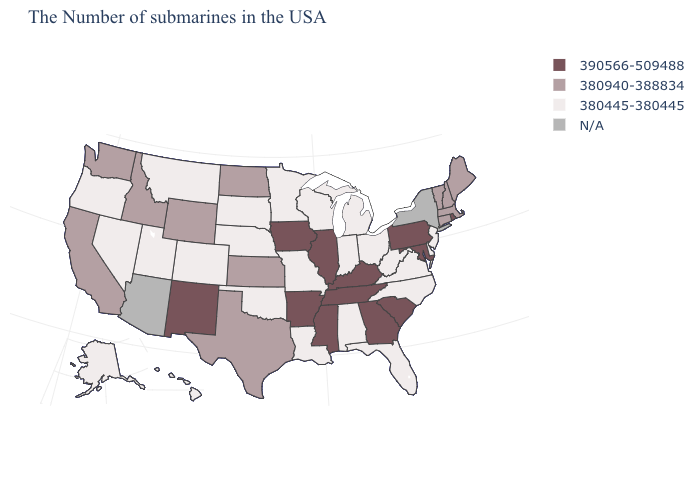Which states have the lowest value in the West?
Give a very brief answer. Colorado, Utah, Montana, Nevada, Oregon, Alaska, Hawaii. What is the value of Michigan?
Keep it brief. 380445-380445. Which states have the lowest value in the MidWest?
Answer briefly. Ohio, Michigan, Indiana, Wisconsin, Missouri, Minnesota, Nebraska, South Dakota. Name the states that have a value in the range 380940-388834?
Keep it brief. Maine, Massachusetts, New Hampshire, Vermont, Connecticut, Kansas, Texas, North Dakota, Wyoming, Idaho, California, Washington. Name the states that have a value in the range N/A?
Concise answer only. New York, Arizona. Among the states that border Alabama , which have the lowest value?
Write a very short answer. Florida. Name the states that have a value in the range N/A?
Be succinct. New York, Arizona. Among the states that border Wisconsin , which have the lowest value?
Give a very brief answer. Michigan, Minnesota. What is the value of Oregon?
Answer briefly. 380445-380445. Name the states that have a value in the range N/A?
Be succinct. New York, Arizona. What is the value of Indiana?
Keep it brief. 380445-380445. Name the states that have a value in the range 380445-380445?
Be succinct. New Jersey, Delaware, Virginia, North Carolina, West Virginia, Ohio, Florida, Michigan, Indiana, Alabama, Wisconsin, Louisiana, Missouri, Minnesota, Nebraska, Oklahoma, South Dakota, Colorado, Utah, Montana, Nevada, Oregon, Alaska, Hawaii. Name the states that have a value in the range 380940-388834?
Concise answer only. Maine, Massachusetts, New Hampshire, Vermont, Connecticut, Kansas, Texas, North Dakota, Wyoming, Idaho, California, Washington. Does the first symbol in the legend represent the smallest category?
Answer briefly. No. 